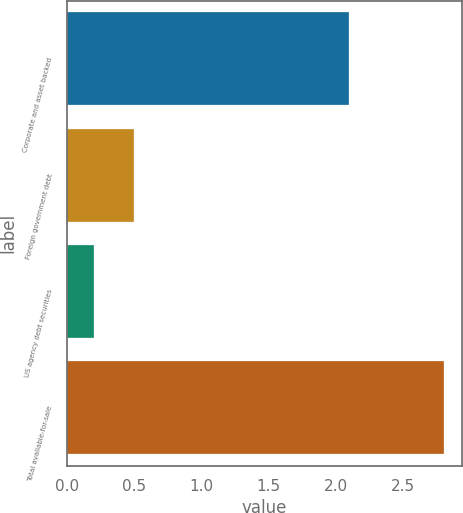Convert chart. <chart><loc_0><loc_0><loc_500><loc_500><bar_chart><fcel>Corporate and asset backed<fcel>Foreign government debt<fcel>US agency debt securities<fcel>Total available-for-sale<nl><fcel>2.1<fcel>0.5<fcel>0.2<fcel>2.8<nl></chart> 